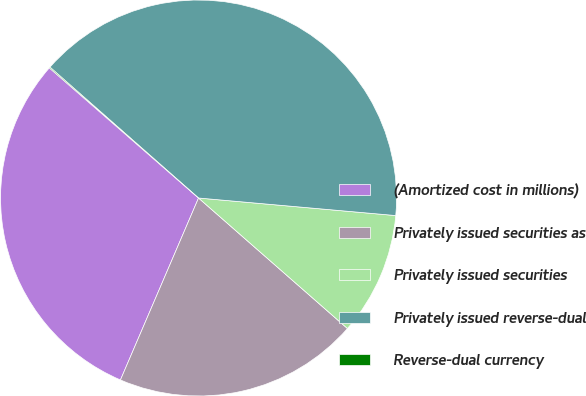Convert chart. <chart><loc_0><loc_0><loc_500><loc_500><pie_chart><fcel>(Amortized cost in millions)<fcel>Privately issued securities as<fcel>Privately issued securities<fcel>Privately issued reverse-dual<fcel>Reverse-dual currency<nl><fcel>29.96%<fcel>20.0%<fcel>10.04%<fcel>39.92%<fcel>0.08%<nl></chart> 